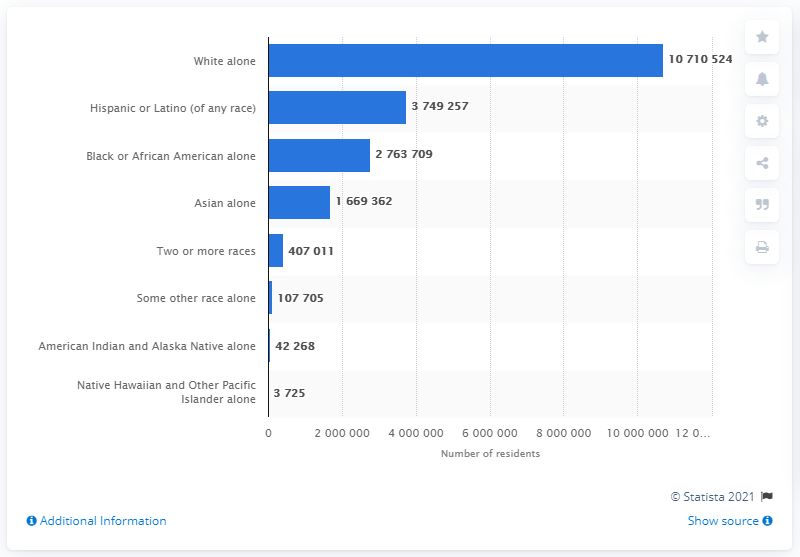List a handful of essential elements in this visual. In 2019, it is estimated that there were approximately 374,925 Hispanic or Latino individuals living in New York. 